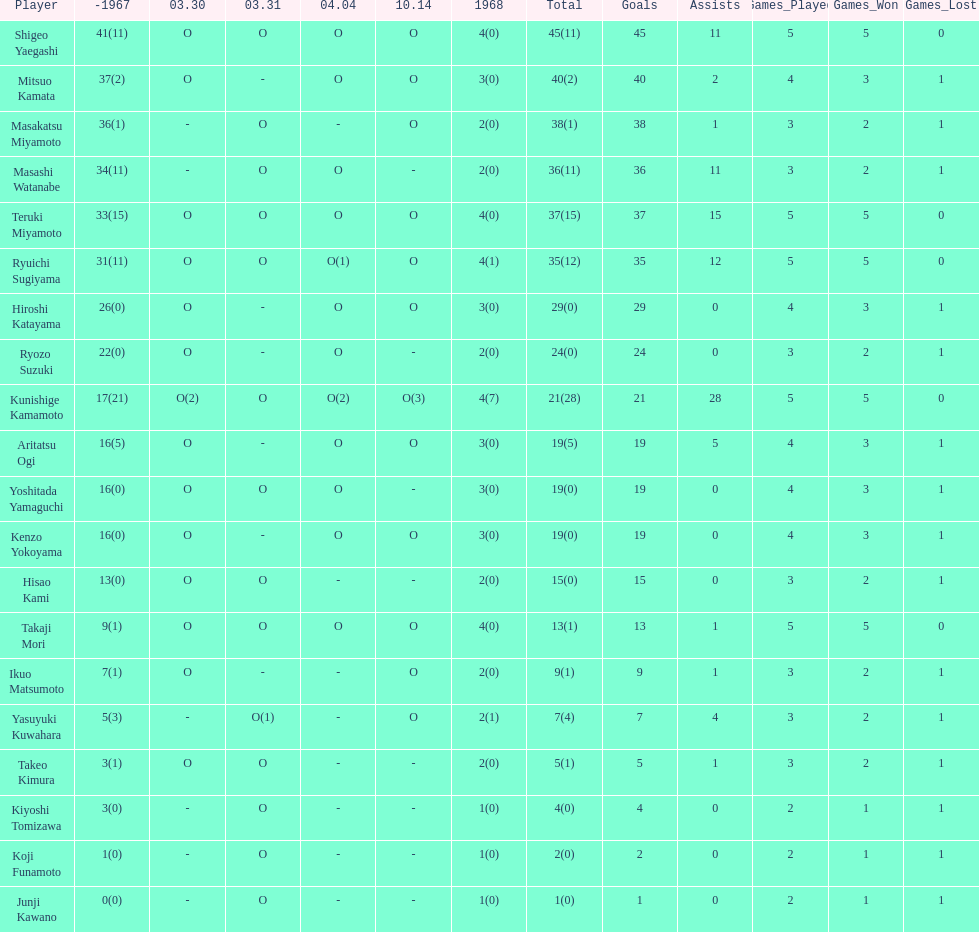Who had more points takaji mori or junji kawano? Takaji Mori. 